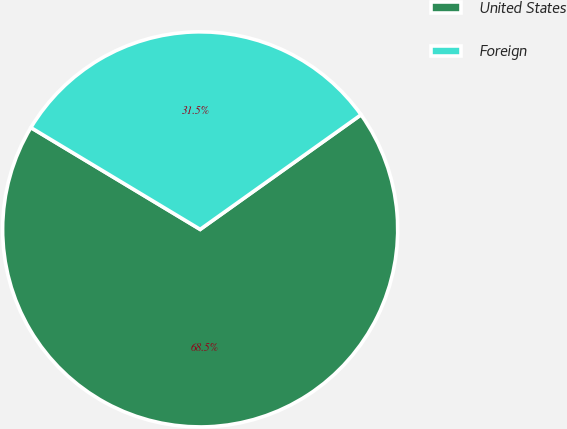Convert chart. <chart><loc_0><loc_0><loc_500><loc_500><pie_chart><fcel>United States<fcel>Foreign<nl><fcel>68.47%<fcel>31.53%<nl></chart> 